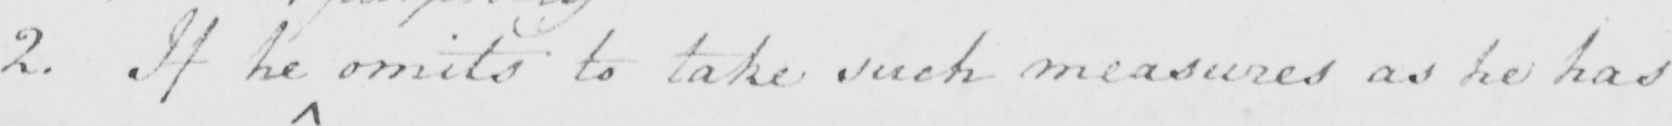Please transcribe the handwritten text in this image. 2 . If he omits to take such measures as he has 